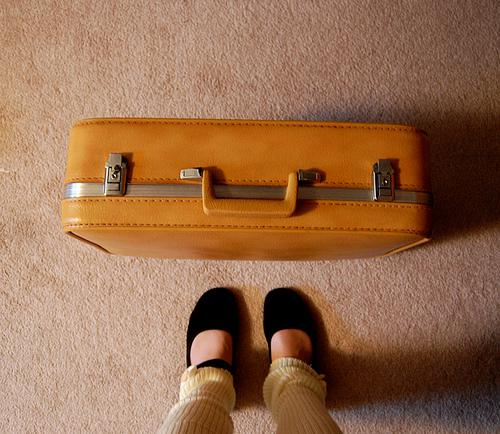Question: what is the subject of the photo?
Choices:
A. Suitcase.
B. Rainbow.
C. Car.
D. Kitten.
Answer with the letter. Answer: A Question: what color are the locks on the suitcase?
Choices:
A. White.
B. Black.
C. Silver.
D. Gray.
Answer with the letter. Answer: C Question: what are the color of the shoes shown?
Choices:
A. Black.
B. Brown.
C. Purple.
D. White.
Answer with the letter. Answer: A Question: what color is the carpet?
Choices:
A. White.
B. Beige.
C. Tan.
D. Brown.
Answer with the letter. Answer: B 